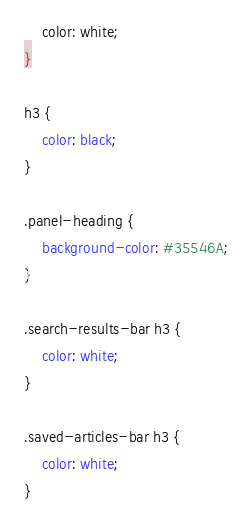Convert code to text. <code><loc_0><loc_0><loc_500><loc_500><_CSS_>    color: white;
}

h3 {
    color: black;
}

.panel-heading {
    background-color: #35546A;
}

.search-results-bar h3 {
    color: white;
}

.saved-articles-bar h3 {
    color: white;
}</code> 